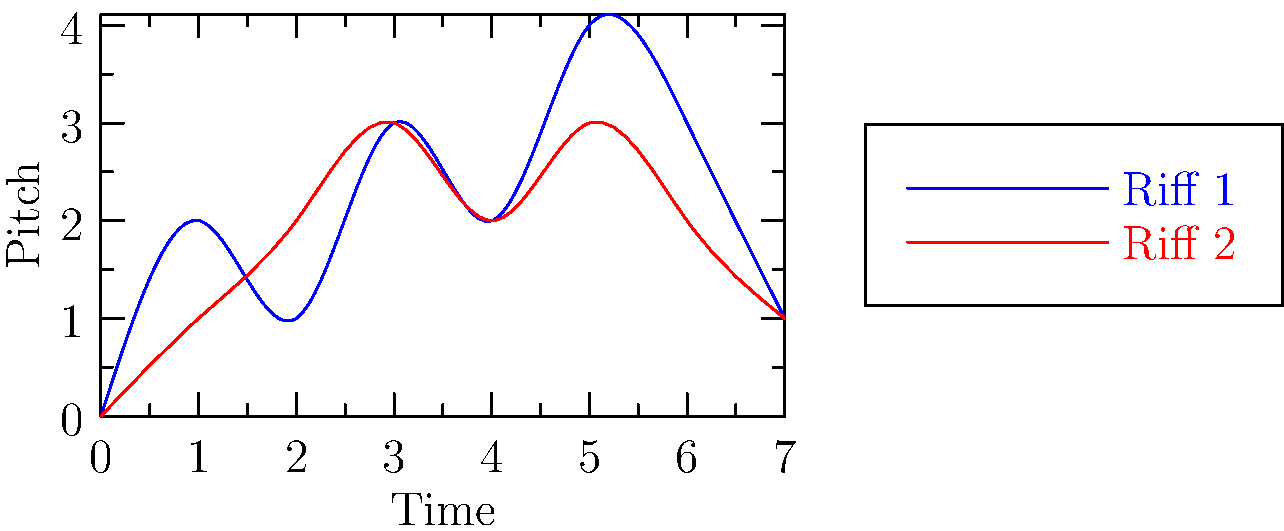Two bass guitar riffs are represented as vectors in 8-dimensional space, where each dimension corresponds to a note's pitch at a specific time. The blue curve represents Riff 1 with vector $\mathbf{a} = (0,2,1,3,2,4,3,1)$, and the red curve represents Riff 2 with vector $\mathbf{b} = (0,1,2,3,2,3,2,1)$. Calculate the cosine similarity between these two riffs using the dot product formula:

$$\cos \theta = \frac{\mathbf{a} \cdot \mathbf{b}}{\|\mathbf{a}\| \|\mathbf{b}\|}$$

Round your answer to three decimal places. To calculate the cosine similarity between the two riff vectors, we'll follow these steps:

1. Calculate the dot product $\mathbf{a} \cdot \mathbf{b}$:
   $\mathbf{a} \cdot \mathbf{b} = (0)(0) + (2)(1) + (1)(2) + (3)(3) + (2)(2) + (4)(3) + (3)(2) + (1)(1)$
   $\mathbf{a} \cdot \mathbf{b} = 0 + 2 + 2 + 9 + 4 + 12 + 6 + 1 = 36$

2. Calculate the magnitude of vector $\mathbf{a}$:
   $\|\mathbf{a}\| = \sqrt{0^2 + 2^2 + 1^2 + 3^2 + 2^2 + 4^2 + 3^2 + 1^2}$
   $\|\mathbf{a}\| = \sqrt{44} \approx 6.633$

3. Calculate the magnitude of vector $\mathbf{b}$:
   $\|\mathbf{b}\| = \sqrt{0^2 + 1^2 + 2^2 + 3^2 + 2^2 + 3^2 + 2^2 + 1^2}$
   $\|\mathbf{b}\| = \sqrt{28} \approx 5.292$

4. Apply the cosine similarity formula:
   $\cos \theta = \frac{\mathbf{a} \cdot \mathbf{b}}{\|\mathbf{a}\| \|\mathbf{b}\|} = \frac{36}{(6.633)(5.292)} \approx 0.9326$

5. Round to three decimal places: 0.933

The cosine similarity ranges from -1 to 1, where 1 indicates perfect similarity. A value of 0.933 suggests that these two bass riffs are highly similar in their pitch patterns over time.
Answer: 0.933 